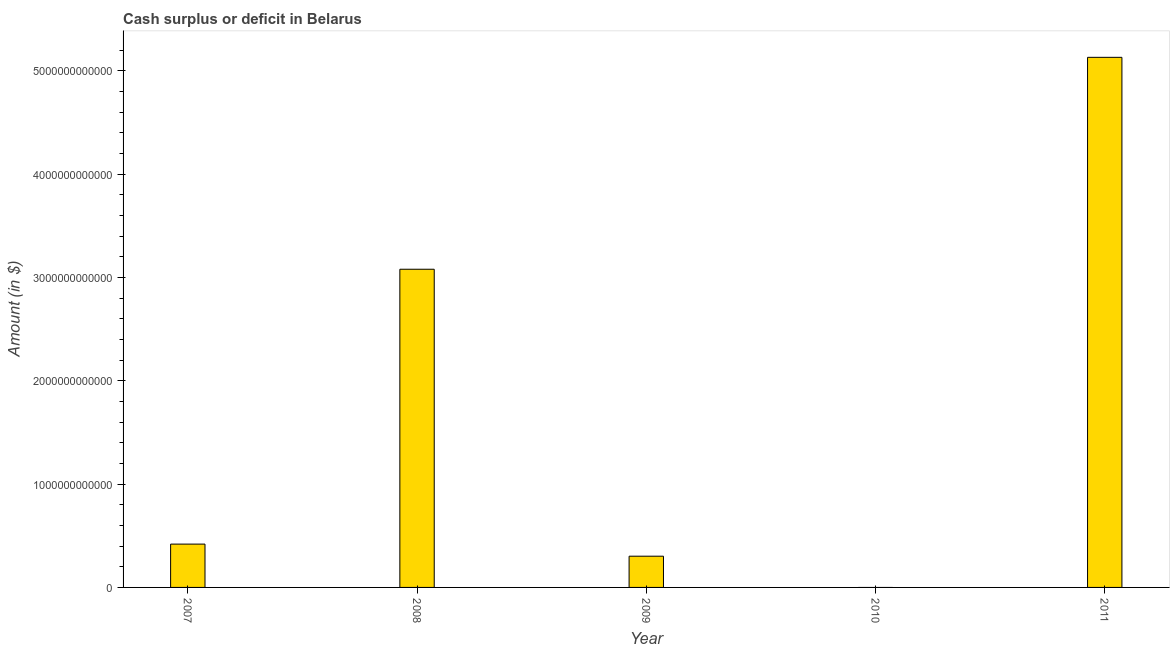Does the graph contain any zero values?
Make the answer very short. Yes. What is the title of the graph?
Make the answer very short. Cash surplus or deficit in Belarus. What is the label or title of the X-axis?
Make the answer very short. Year. What is the label or title of the Y-axis?
Give a very brief answer. Amount (in $). What is the cash surplus or deficit in 2007?
Offer a terse response. 4.19e+11. Across all years, what is the maximum cash surplus or deficit?
Your answer should be very brief. 5.13e+12. What is the sum of the cash surplus or deficit?
Make the answer very short. 8.93e+12. What is the difference between the cash surplus or deficit in 2007 and 2011?
Ensure brevity in your answer.  -4.71e+12. What is the average cash surplus or deficit per year?
Make the answer very short. 1.79e+12. What is the median cash surplus or deficit?
Your answer should be compact. 4.19e+11. In how many years, is the cash surplus or deficit greater than 400000000000 $?
Offer a terse response. 3. What is the ratio of the cash surplus or deficit in 2007 to that in 2008?
Make the answer very short. 0.14. What is the difference between the highest and the second highest cash surplus or deficit?
Keep it short and to the point. 2.05e+12. Is the sum of the cash surplus or deficit in 2008 and 2009 greater than the maximum cash surplus or deficit across all years?
Your answer should be very brief. No. What is the difference between the highest and the lowest cash surplus or deficit?
Provide a succinct answer. 5.13e+12. Are all the bars in the graph horizontal?
Provide a short and direct response. No. What is the difference between two consecutive major ticks on the Y-axis?
Give a very brief answer. 1.00e+12. Are the values on the major ticks of Y-axis written in scientific E-notation?
Give a very brief answer. No. What is the Amount (in $) in 2007?
Your response must be concise. 4.19e+11. What is the Amount (in $) of 2008?
Give a very brief answer. 3.08e+12. What is the Amount (in $) of 2009?
Ensure brevity in your answer.  3.02e+11. What is the Amount (in $) of 2010?
Keep it short and to the point. 0. What is the Amount (in $) in 2011?
Your response must be concise. 5.13e+12. What is the difference between the Amount (in $) in 2007 and 2008?
Ensure brevity in your answer.  -2.66e+12. What is the difference between the Amount (in $) in 2007 and 2009?
Your answer should be compact. 1.17e+11. What is the difference between the Amount (in $) in 2007 and 2011?
Provide a short and direct response. -4.71e+12. What is the difference between the Amount (in $) in 2008 and 2009?
Offer a terse response. 2.78e+12. What is the difference between the Amount (in $) in 2008 and 2011?
Your answer should be compact. -2.05e+12. What is the difference between the Amount (in $) in 2009 and 2011?
Ensure brevity in your answer.  -4.83e+12. What is the ratio of the Amount (in $) in 2007 to that in 2008?
Ensure brevity in your answer.  0.14. What is the ratio of the Amount (in $) in 2007 to that in 2009?
Keep it short and to the point. 1.39. What is the ratio of the Amount (in $) in 2007 to that in 2011?
Your answer should be compact. 0.08. What is the ratio of the Amount (in $) in 2008 to that in 2009?
Your answer should be very brief. 10.19. What is the ratio of the Amount (in $) in 2009 to that in 2011?
Make the answer very short. 0.06. 